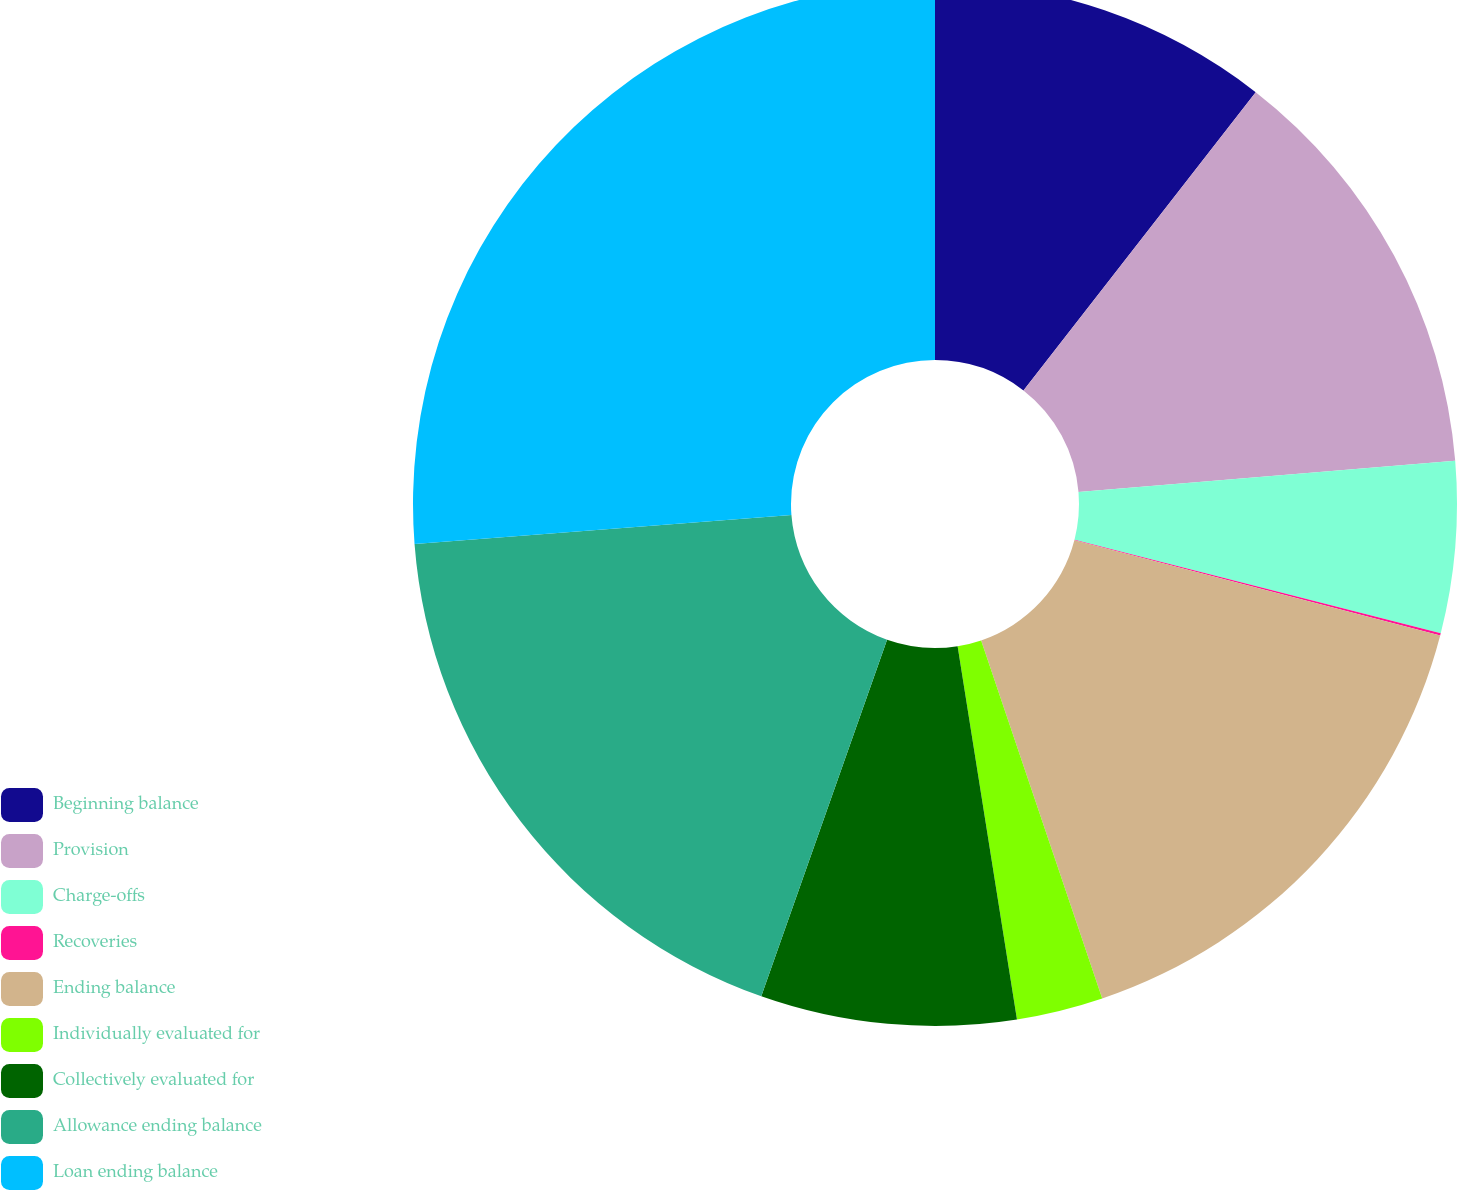Convert chart. <chart><loc_0><loc_0><loc_500><loc_500><pie_chart><fcel>Beginning balance<fcel>Provision<fcel>Charge-offs<fcel>Recoveries<fcel>Ending balance<fcel>Individually evaluated for<fcel>Collectively evaluated for<fcel>Allowance ending balance<fcel>Loan ending balance<nl><fcel>10.53%<fcel>13.15%<fcel>5.3%<fcel>0.07%<fcel>15.76%<fcel>2.68%<fcel>7.91%<fcel>18.38%<fcel>26.22%<nl></chart> 